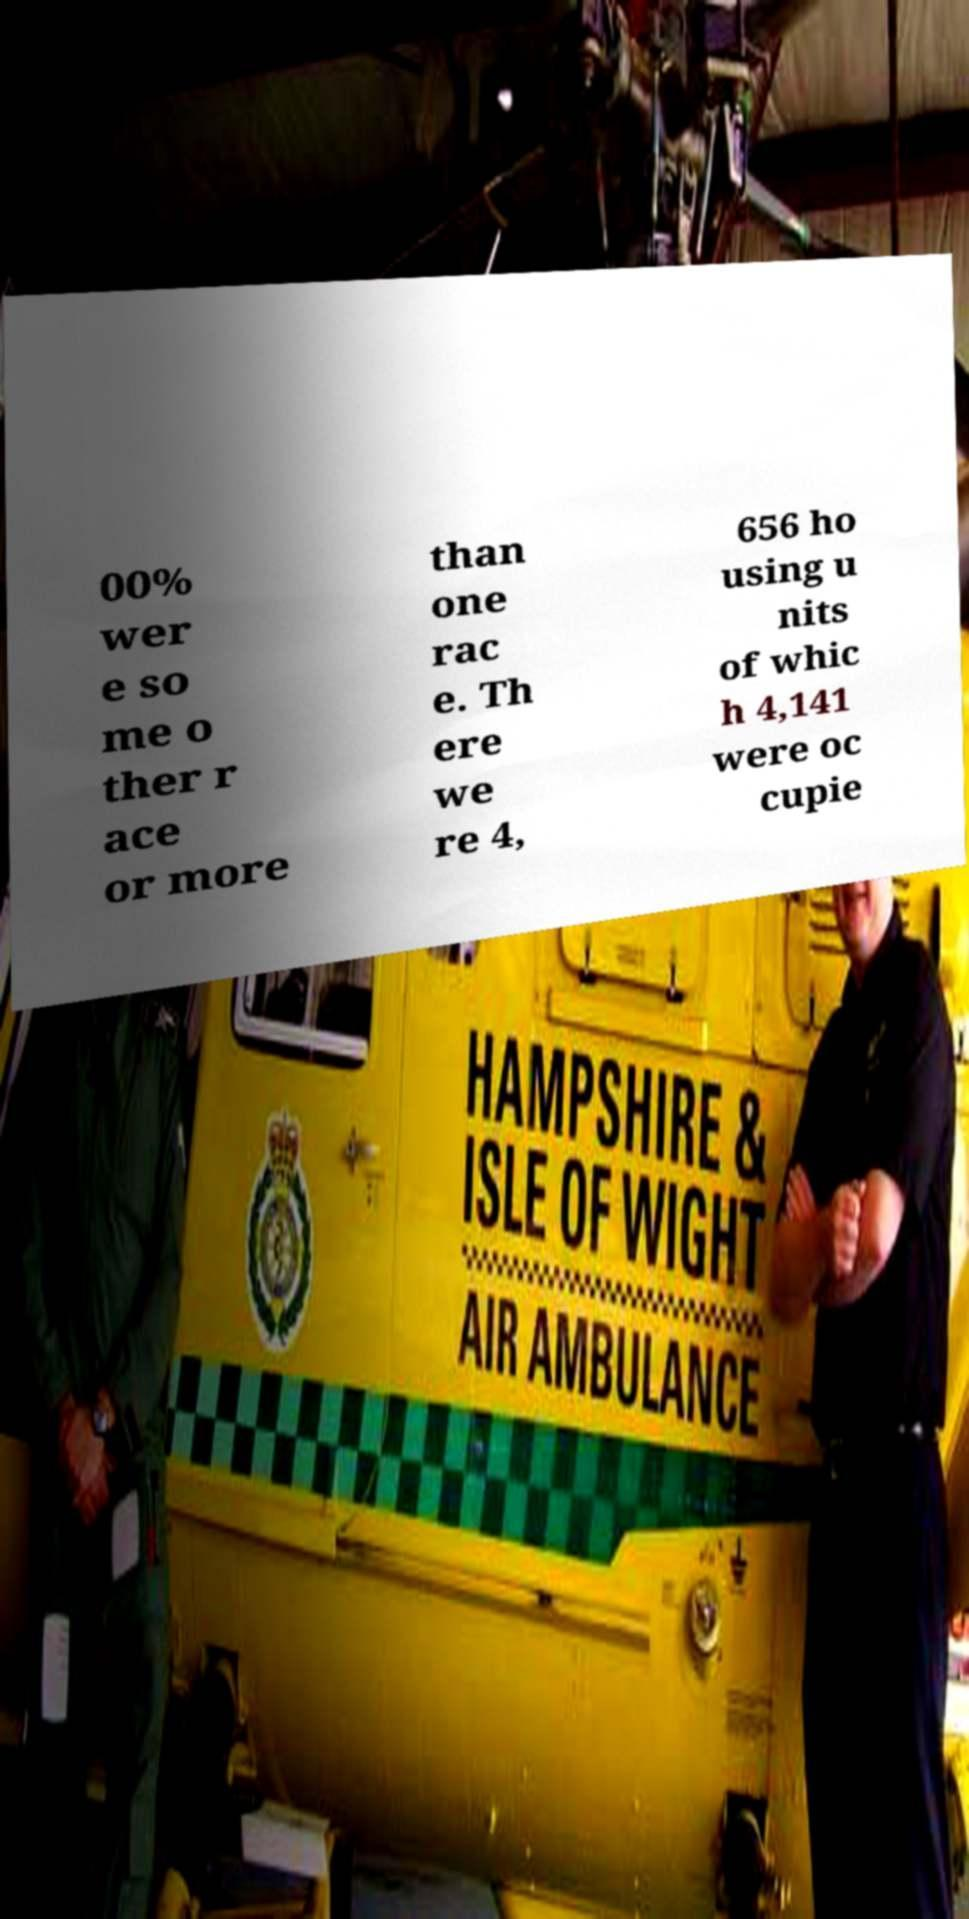Could you assist in decoding the text presented in this image and type it out clearly? 00% wer e so me o ther r ace or more than one rac e. Th ere we re 4, 656 ho using u nits of whic h 4,141 were oc cupie 